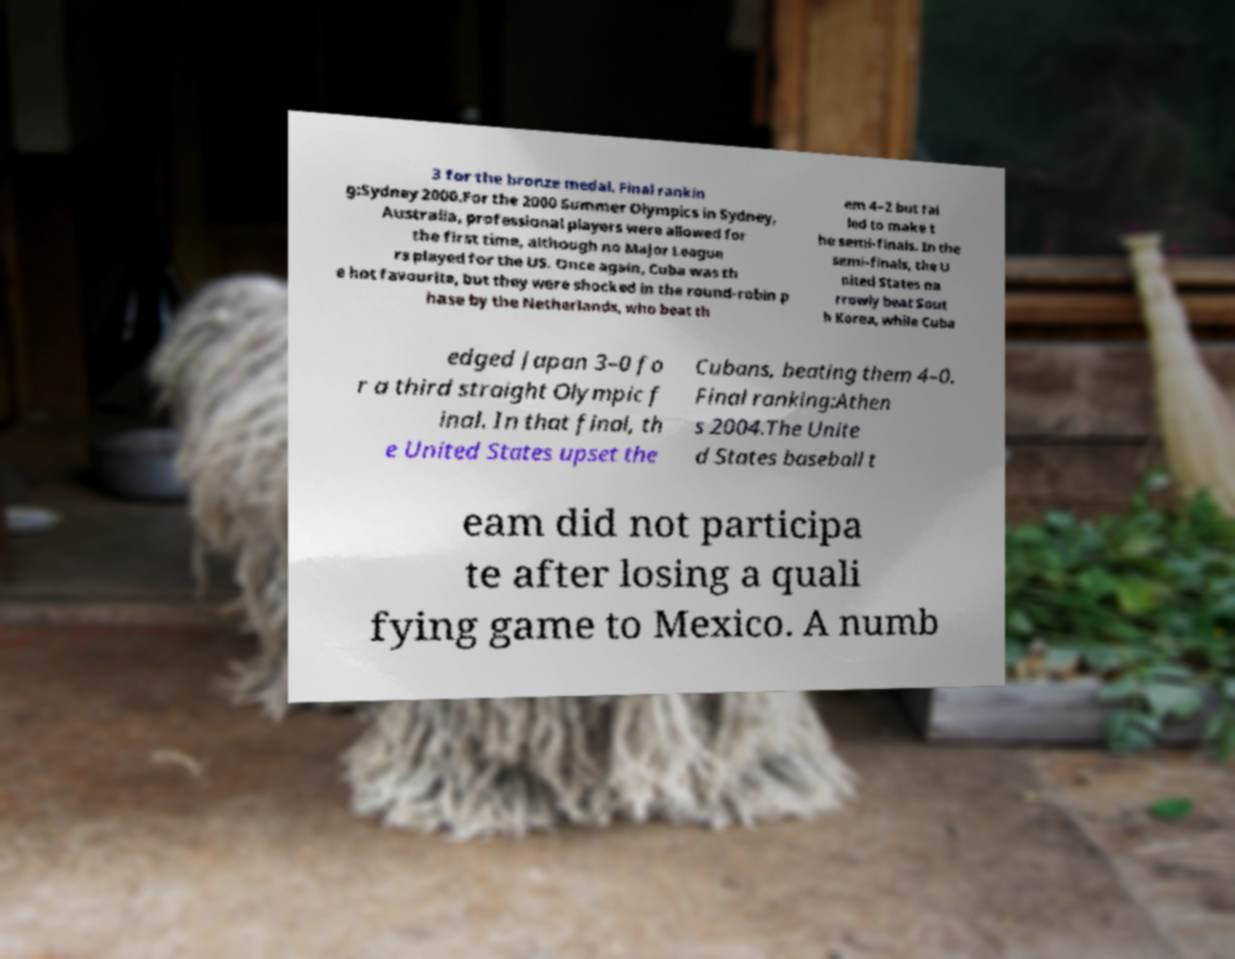What messages or text are displayed in this image? I need them in a readable, typed format. 3 for the bronze medal. Final rankin g:Sydney 2000.For the 2000 Summer Olympics in Sydney, Australia, professional players were allowed for the first time, although no Major League rs played for the US. Once again, Cuba was th e hot favourite, but they were shocked in the round-robin p hase by the Netherlands, who beat th em 4–2 but fai led to make t he semi-finals. In the semi-finals, the U nited States na rrowly beat Sout h Korea, while Cuba edged Japan 3–0 fo r a third straight Olympic f inal. In that final, th e United States upset the Cubans, beating them 4–0. Final ranking:Athen s 2004.The Unite d States baseball t eam did not participa te after losing a quali fying game to Mexico. A numb 